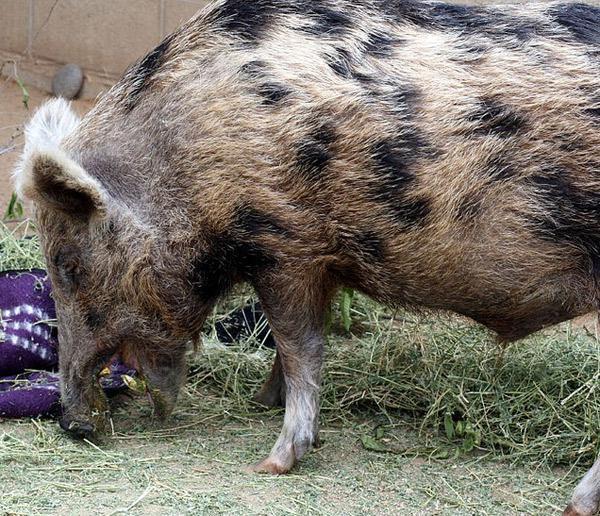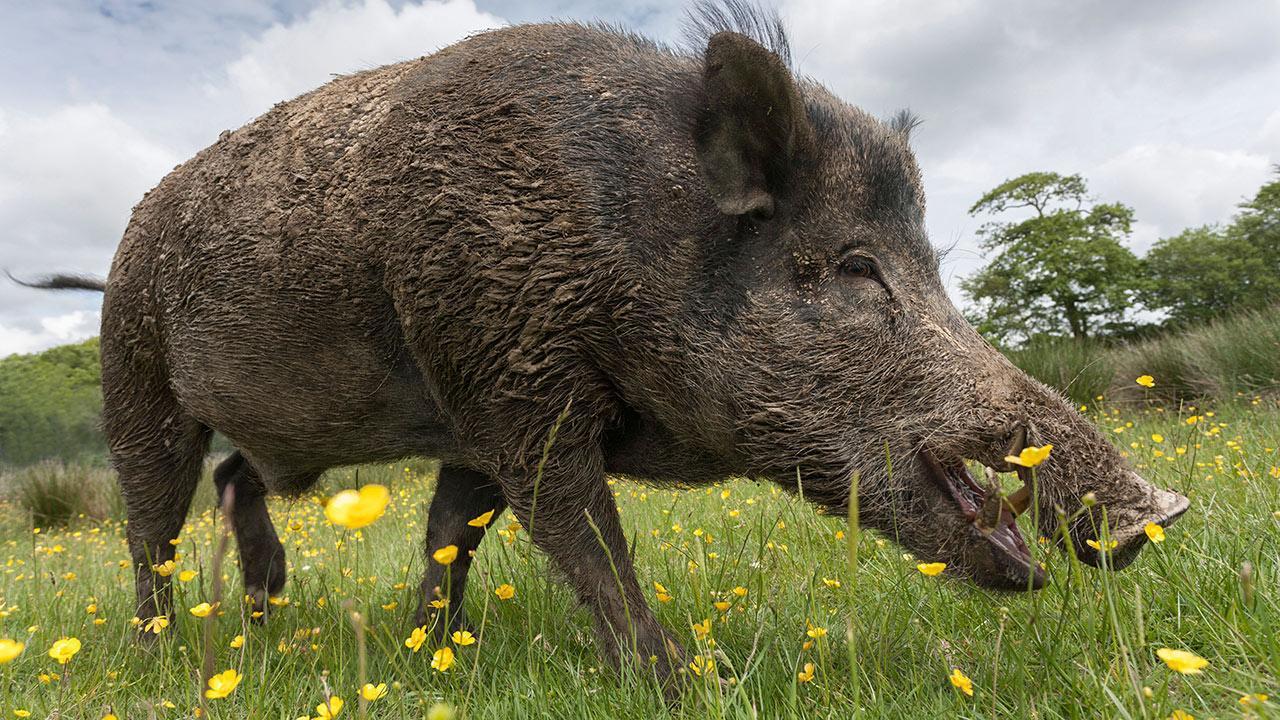The first image is the image on the left, the second image is the image on the right. Given the left and right images, does the statement "There are exactly two boars, and they don't look like the same boar." hold true? Answer yes or no. Yes. 